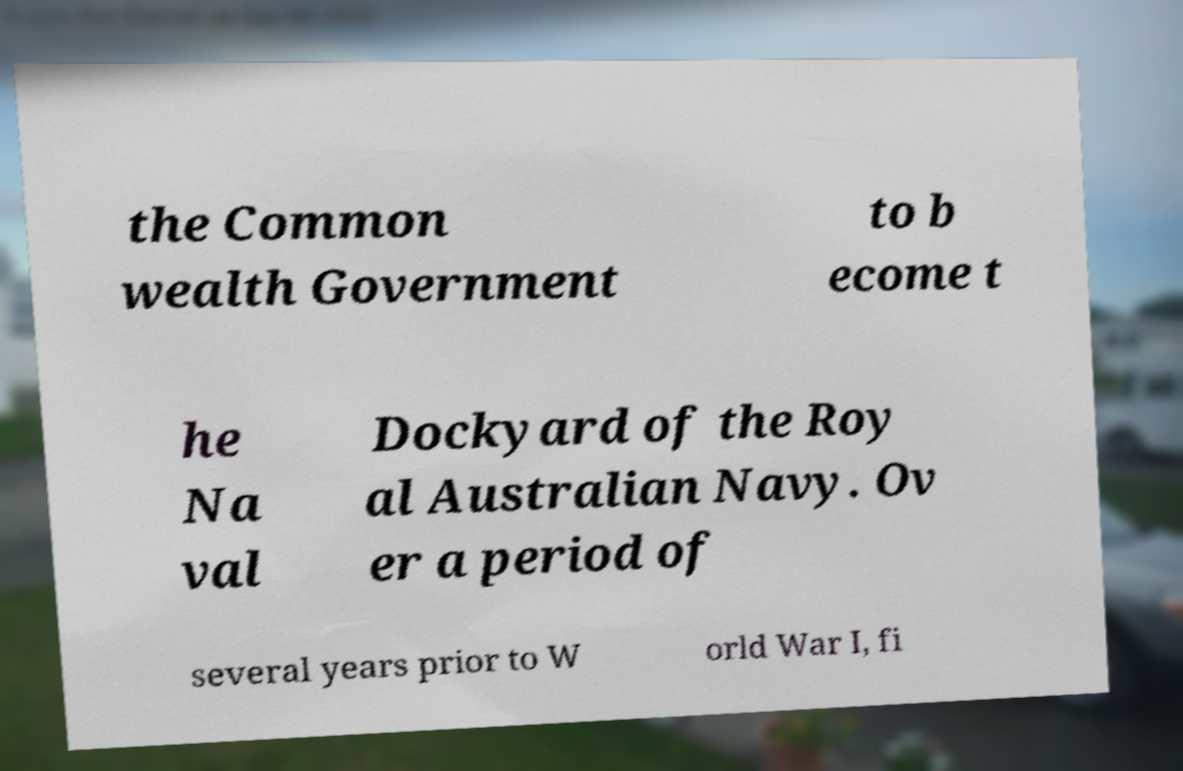Can you accurately transcribe the text from the provided image for me? the Common wealth Government to b ecome t he Na val Dockyard of the Roy al Australian Navy. Ov er a period of several years prior to W orld War I, fi 